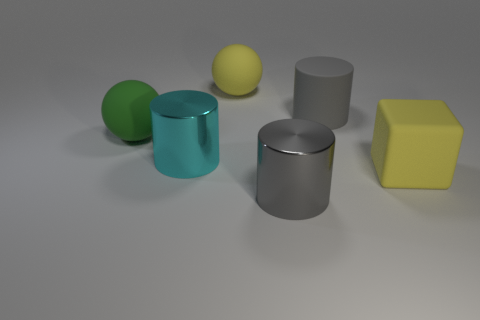Add 2 cyan spheres. How many objects exist? 8 Subtract all cubes. How many objects are left? 5 Add 5 large matte cylinders. How many large matte cylinders exist? 6 Subtract 0 brown blocks. How many objects are left? 6 Subtract all tiny cylinders. Subtract all large gray cylinders. How many objects are left? 4 Add 2 big gray rubber cylinders. How many big gray rubber cylinders are left? 3 